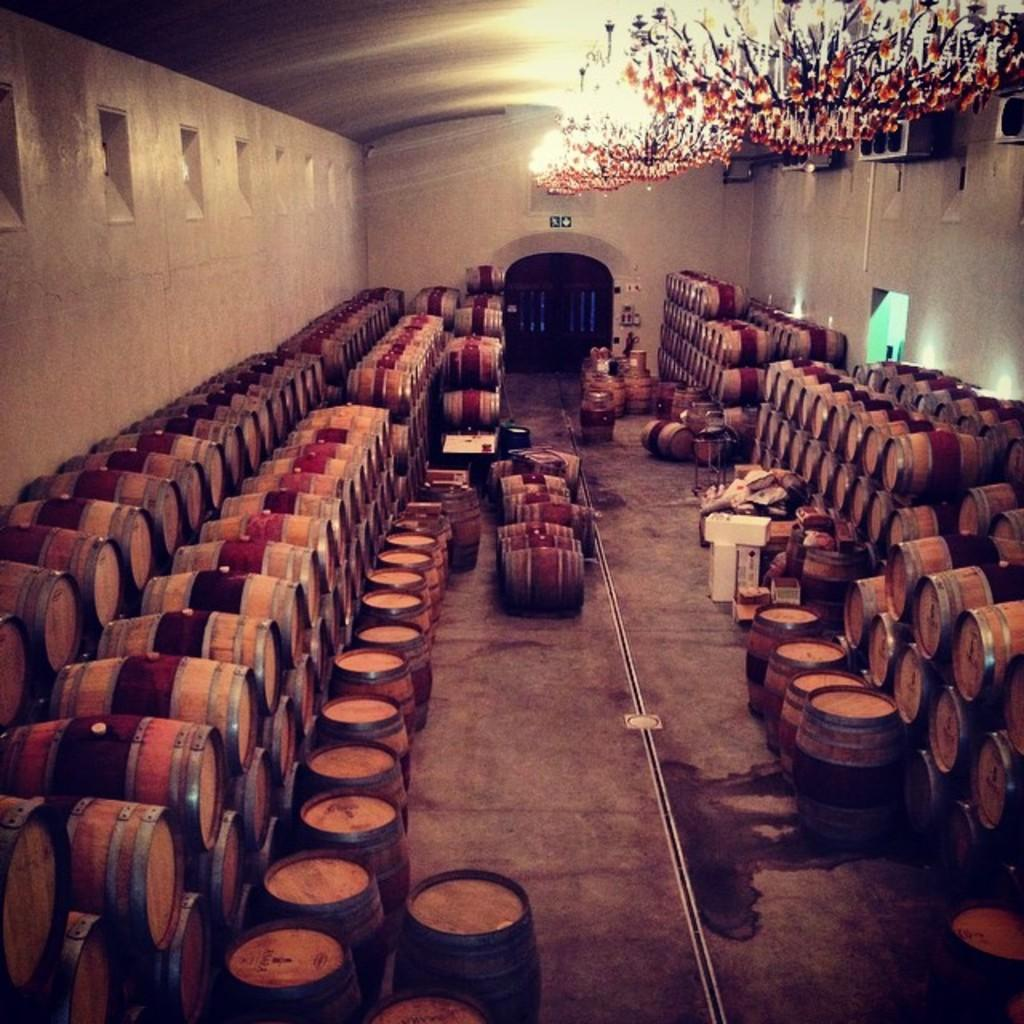What type of objects are in the image? There are wooden barrels in the image. How are the wooden barrels arranged? The wooden barrels are arranged in a row. What else can be seen in the image? There are lights on the roof in the image. Can you see any veins in the wooden barrels in the image? There are no veins present in the wooden barrels in the image, as veins are a biological feature found in living organisms. On which side of the barrels are the lights located? The provided facts do not specify the side of the barrels where the lights are located. 